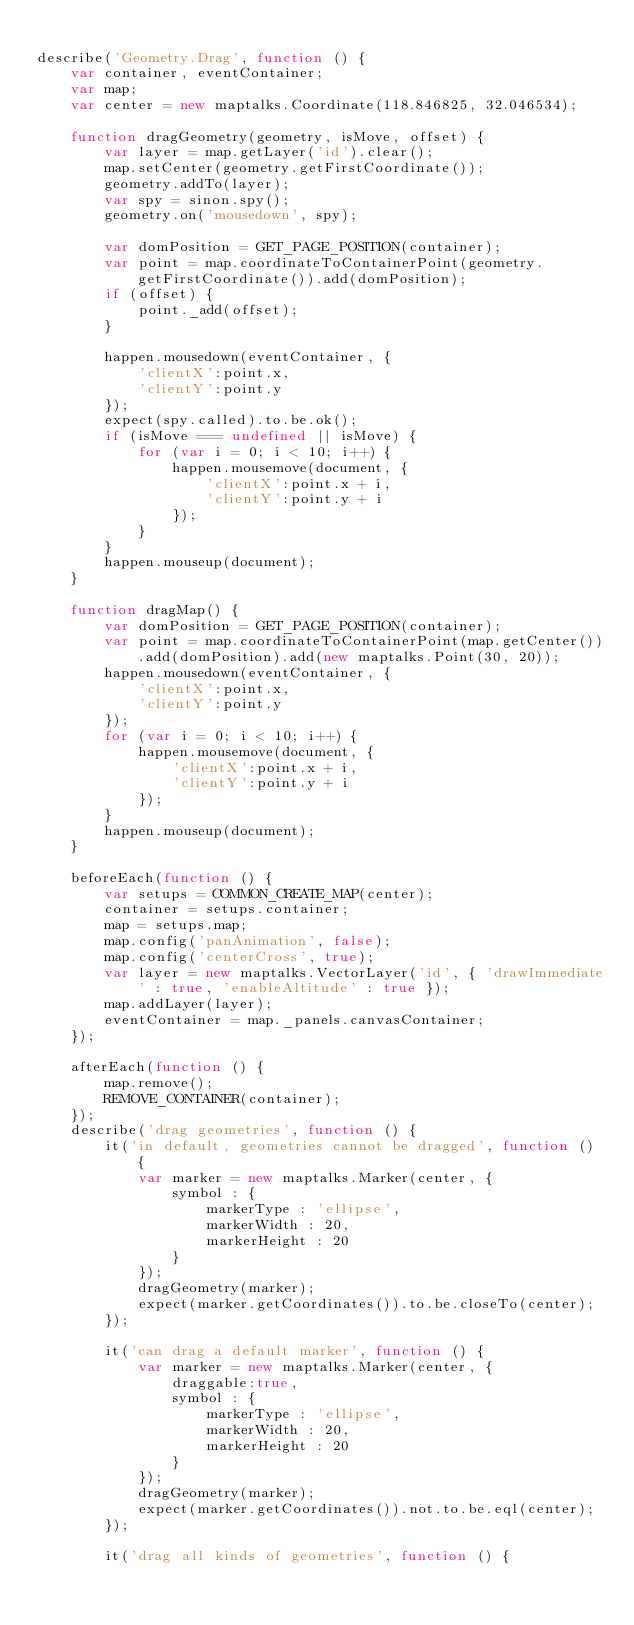Convert code to text. <code><loc_0><loc_0><loc_500><loc_500><_JavaScript_>
describe('Geometry.Drag', function () {
    var container, eventContainer;
    var map;
    var center = new maptalks.Coordinate(118.846825, 32.046534);

    function dragGeometry(geometry, isMove, offset) {
        var layer = map.getLayer('id').clear();
        map.setCenter(geometry.getFirstCoordinate());
        geometry.addTo(layer);
        var spy = sinon.spy();
        geometry.on('mousedown', spy);

        var domPosition = GET_PAGE_POSITION(container);
        var point = map.coordinateToContainerPoint(geometry.getFirstCoordinate()).add(domPosition);
        if (offset) {
            point._add(offset);
        }

        happen.mousedown(eventContainer, {
            'clientX':point.x,
            'clientY':point.y
        });
        expect(spy.called).to.be.ok();
        if (isMove === undefined || isMove) {
            for (var i = 0; i < 10; i++) {
                happen.mousemove(document, {
                    'clientX':point.x + i,
                    'clientY':point.y + i
                });
            }
        }
        happen.mouseup(document);
    }

    function dragMap() {
        var domPosition = GET_PAGE_POSITION(container);
        var point = map.coordinateToContainerPoint(map.getCenter()).add(domPosition).add(new maptalks.Point(30, 20));
        happen.mousedown(eventContainer, {
            'clientX':point.x,
            'clientY':point.y
        });
        for (var i = 0; i < 10; i++) {
            happen.mousemove(document, {
                'clientX':point.x + i,
                'clientY':point.y + i
            });
        }
        happen.mouseup(document);
    }

    beforeEach(function () {
        var setups = COMMON_CREATE_MAP(center);
        container = setups.container;
        map = setups.map;
        map.config('panAnimation', false);
        map.config('centerCross', true);
        var layer = new maptalks.VectorLayer('id', { 'drawImmediate' : true, 'enableAltitude' : true });
        map.addLayer(layer);
        eventContainer = map._panels.canvasContainer;
    });

    afterEach(function () {
        map.remove();
        REMOVE_CONTAINER(container);
    });
    describe('drag geometries', function () {
        it('in default, geometries cannot be dragged', function () {
            var marker = new maptalks.Marker(center, {
                symbol : {
                    markerType : 'ellipse',
                    markerWidth : 20,
                    markerHeight : 20
                }
            });
            dragGeometry(marker);
            expect(marker.getCoordinates()).to.be.closeTo(center);
        });

        it('can drag a default marker', function () {
            var marker = new maptalks.Marker(center, {
                draggable:true,
                symbol : {
                    markerType : 'ellipse',
                    markerWidth : 20,
                    markerHeight : 20
                }
            });
            dragGeometry(marker);
            expect(marker.getCoordinates()).not.to.be.eql(center);
        });

        it('drag all kinds of geometries', function () {</code> 